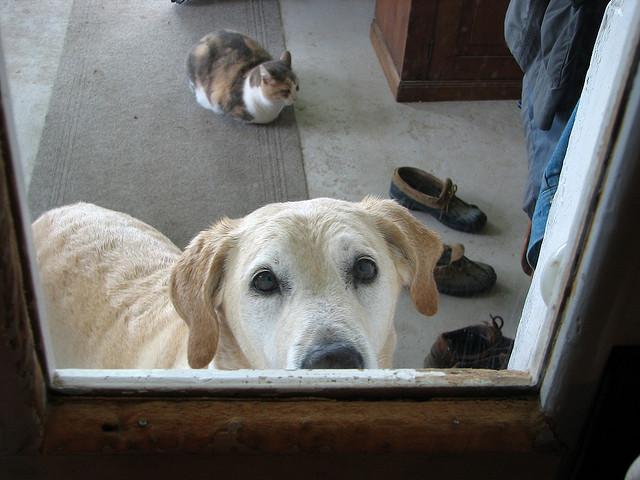What color is the dog?
Write a very short answer. Tan. How many animals are in this photo?
Short answer required. 2. What breed of dog is this?
Keep it brief. Lab. Are there two animals?
Concise answer only. Yes. 